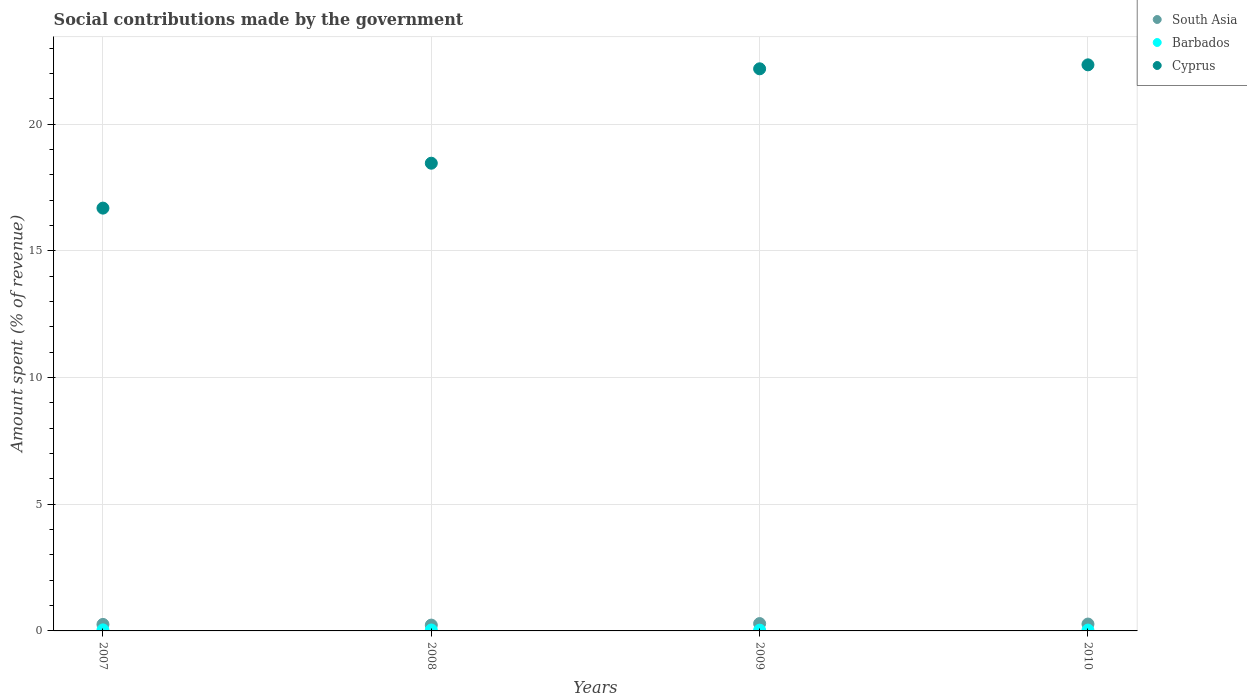What is the amount spent (in %) on social contributions in Barbados in 2010?
Your answer should be compact. 0.03. Across all years, what is the maximum amount spent (in %) on social contributions in South Asia?
Keep it short and to the point. 0.29. Across all years, what is the minimum amount spent (in %) on social contributions in Cyprus?
Offer a terse response. 16.69. In which year was the amount spent (in %) on social contributions in Cyprus minimum?
Provide a succinct answer. 2007. What is the total amount spent (in %) on social contributions in South Asia in the graph?
Ensure brevity in your answer.  1.05. What is the difference between the amount spent (in %) on social contributions in Barbados in 2007 and that in 2009?
Your answer should be compact. 0.01. What is the difference between the amount spent (in %) on social contributions in Barbados in 2009 and the amount spent (in %) on social contributions in Cyprus in 2007?
Your response must be concise. -16.66. What is the average amount spent (in %) on social contributions in Barbados per year?
Provide a short and direct response. 0.03. In the year 2009, what is the difference between the amount spent (in %) on social contributions in South Asia and amount spent (in %) on social contributions in Cyprus?
Offer a terse response. -21.9. In how many years, is the amount spent (in %) on social contributions in South Asia greater than 12 %?
Offer a terse response. 0. What is the ratio of the amount spent (in %) on social contributions in South Asia in 2007 to that in 2008?
Provide a short and direct response. 1.12. Is the difference between the amount spent (in %) on social contributions in South Asia in 2009 and 2010 greater than the difference between the amount spent (in %) on social contributions in Cyprus in 2009 and 2010?
Offer a very short reply. Yes. What is the difference between the highest and the second highest amount spent (in %) on social contributions in Cyprus?
Give a very brief answer. 0.16. What is the difference between the highest and the lowest amount spent (in %) on social contributions in Cyprus?
Give a very brief answer. 5.66. Is the amount spent (in %) on social contributions in South Asia strictly greater than the amount spent (in %) on social contributions in Cyprus over the years?
Make the answer very short. No. Is the amount spent (in %) on social contributions in Cyprus strictly less than the amount spent (in %) on social contributions in Barbados over the years?
Offer a terse response. No. How many dotlines are there?
Your answer should be very brief. 3. Where does the legend appear in the graph?
Your answer should be compact. Top right. What is the title of the graph?
Give a very brief answer. Social contributions made by the government. What is the label or title of the Y-axis?
Provide a succinct answer. Amount spent (% of revenue). What is the Amount spent (% of revenue) of South Asia in 2007?
Provide a short and direct response. 0.26. What is the Amount spent (% of revenue) in Barbados in 2007?
Provide a short and direct response. 0.04. What is the Amount spent (% of revenue) in Cyprus in 2007?
Provide a succinct answer. 16.69. What is the Amount spent (% of revenue) in South Asia in 2008?
Ensure brevity in your answer.  0.23. What is the Amount spent (% of revenue) in Barbados in 2008?
Your response must be concise. 0.04. What is the Amount spent (% of revenue) in Cyprus in 2008?
Provide a short and direct response. 18.46. What is the Amount spent (% of revenue) in South Asia in 2009?
Provide a short and direct response. 0.29. What is the Amount spent (% of revenue) in Barbados in 2009?
Make the answer very short. 0.03. What is the Amount spent (% of revenue) of Cyprus in 2009?
Provide a short and direct response. 22.19. What is the Amount spent (% of revenue) in South Asia in 2010?
Offer a very short reply. 0.27. What is the Amount spent (% of revenue) of Barbados in 2010?
Give a very brief answer. 0.03. What is the Amount spent (% of revenue) of Cyprus in 2010?
Offer a very short reply. 22.35. Across all years, what is the maximum Amount spent (% of revenue) in South Asia?
Provide a short and direct response. 0.29. Across all years, what is the maximum Amount spent (% of revenue) in Barbados?
Your answer should be compact. 0.04. Across all years, what is the maximum Amount spent (% of revenue) in Cyprus?
Provide a succinct answer. 22.35. Across all years, what is the minimum Amount spent (% of revenue) in South Asia?
Make the answer very short. 0.23. Across all years, what is the minimum Amount spent (% of revenue) of Barbados?
Keep it short and to the point. 0.03. Across all years, what is the minimum Amount spent (% of revenue) in Cyprus?
Your answer should be very brief. 16.69. What is the total Amount spent (% of revenue) in South Asia in the graph?
Provide a short and direct response. 1.05. What is the total Amount spent (% of revenue) of Barbados in the graph?
Make the answer very short. 0.14. What is the total Amount spent (% of revenue) in Cyprus in the graph?
Your answer should be very brief. 79.69. What is the difference between the Amount spent (% of revenue) in South Asia in 2007 and that in 2008?
Your answer should be very brief. 0.03. What is the difference between the Amount spent (% of revenue) in Barbados in 2007 and that in 2008?
Your answer should be very brief. 0. What is the difference between the Amount spent (% of revenue) of Cyprus in 2007 and that in 2008?
Your answer should be compact. -1.77. What is the difference between the Amount spent (% of revenue) in South Asia in 2007 and that in 2009?
Give a very brief answer. -0.03. What is the difference between the Amount spent (% of revenue) in Barbados in 2007 and that in 2009?
Keep it short and to the point. 0.01. What is the difference between the Amount spent (% of revenue) of Cyprus in 2007 and that in 2009?
Provide a short and direct response. -5.5. What is the difference between the Amount spent (% of revenue) of South Asia in 2007 and that in 2010?
Ensure brevity in your answer.  -0.01. What is the difference between the Amount spent (% of revenue) in Barbados in 2007 and that in 2010?
Offer a very short reply. 0.01. What is the difference between the Amount spent (% of revenue) of Cyprus in 2007 and that in 2010?
Give a very brief answer. -5.66. What is the difference between the Amount spent (% of revenue) in South Asia in 2008 and that in 2009?
Your answer should be compact. -0.06. What is the difference between the Amount spent (% of revenue) of Barbados in 2008 and that in 2009?
Keep it short and to the point. 0.01. What is the difference between the Amount spent (% of revenue) of Cyprus in 2008 and that in 2009?
Offer a very short reply. -3.73. What is the difference between the Amount spent (% of revenue) in South Asia in 2008 and that in 2010?
Offer a very short reply. -0.04. What is the difference between the Amount spent (% of revenue) of Barbados in 2008 and that in 2010?
Offer a terse response. 0. What is the difference between the Amount spent (% of revenue) in Cyprus in 2008 and that in 2010?
Provide a succinct answer. -3.88. What is the difference between the Amount spent (% of revenue) in South Asia in 2009 and that in 2010?
Provide a succinct answer. 0.02. What is the difference between the Amount spent (% of revenue) in Barbados in 2009 and that in 2010?
Your answer should be very brief. -0. What is the difference between the Amount spent (% of revenue) in Cyprus in 2009 and that in 2010?
Give a very brief answer. -0.16. What is the difference between the Amount spent (% of revenue) in South Asia in 2007 and the Amount spent (% of revenue) in Barbados in 2008?
Make the answer very short. 0.22. What is the difference between the Amount spent (% of revenue) in South Asia in 2007 and the Amount spent (% of revenue) in Cyprus in 2008?
Ensure brevity in your answer.  -18.21. What is the difference between the Amount spent (% of revenue) in Barbados in 2007 and the Amount spent (% of revenue) in Cyprus in 2008?
Your answer should be very brief. -18.42. What is the difference between the Amount spent (% of revenue) of South Asia in 2007 and the Amount spent (% of revenue) of Barbados in 2009?
Keep it short and to the point. 0.23. What is the difference between the Amount spent (% of revenue) in South Asia in 2007 and the Amount spent (% of revenue) in Cyprus in 2009?
Give a very brief answer. -21.93. What is the difference between the Amount spent (% of revenue) of Barbados in 2007 and the Amount spent (% of revenue) of Cyprus in 2009?
Your response must be concise. -22.15. What is the difference between the Amount spent (% of revenue) in South Asia in 2007 and the Amount spent (% of revenue) in Barbados in 2010?
Ensure brevity in your answer.  0.22. What is the difference between the Amount spent (% of revenue) in South Asia in 2007 and the Amount spent (% of revenue) in Cyprus in 2010?
Give a very brief answer. -22.09. What is the difference between the Amount spent (% of revenue) in Barbados in 2007 and the Amount spent (% of revenue) in Cyprus in 2010?
Keep it short and to the point. -22.31. What is the difference between the Amount spent (% of revenue) in South Asia in 2008 and the Amount spent (% of revenue) in Barbados in 2009?
Your answer should be very brief. 0.2. What is the difference between the Amount spent (% of revenue) of South Asia in 2008 and the Amount spent (% of revenue) of Cyprus in 2009?
Keep it short and to the point. -21.96. What is the difference between the Amount spent (% of revenue) in Barbados in 2008 and the Amount spent (% of revenue) in Cyprus in 2009?
Give a very brief answer. -22.15. What is the difference between the Amount spent (% of revenue) of South Asia in 2008 and the Amount spent (% of revenue) of Barbados in 2010?
Your answer should be compact. 0.2. What is the difference between the Amount spent (% of revenue) in South Asia in 2008 and the Amount spent (% of revenue) in Cyprus in 2010?
Your answer should be very brief. -22.12. What is the difference between the Amount spent (% of revenue) in Barbados in 2008 and the Amount spent (% of revenue) in Cyprus in 2010?
Ensure brevity in your answer.  -22.31. What is the difference between the Amount spent (% of revenue) of South Asia in 2009 and the Amount spent (% of revenue) of Barbados in 2010?
Offer a terse response. 0.26. What is the difference between the Amount spent (% of revenue) of South Asia in 2009 and the Amount spent (% of revenue) of Cyprus in 2010?
Give a very brief answer. -22.06. What is the difference between the Amount spent (% of revenue) of Barbados in 2009 and the Amount spent (% of revenue) of Cyprus in 2010?
Your answer should be very brief. -22.32. What is the average Amount spent (% of revenue) in South Asia per year?
Make the answer very short. 0.26. What is the average Amount spent (% of revenue) of Barbados per year?
Your response must be concise. 0.03. What is the average Amount spent (% of revenue) of Cyprus per year?
Give a very brief answer. 19.92. In the year 2007, what is the difference between the Amount spent (% of revenue) of South Asia and Amount spent (% of revenue) of Barbados?
Offer a terse response. 0.22. In the year 2007, what is the difference between the Amount spent (% of revenue) of South Asia and Amount spent (% of revenue) of Cyprus?
Your answer should be compact. -16.43. In the year 2007, what is the difference between the Amount spent (% of revenue) in Barbados and Amount spent (% of revenue) in Cyprus?
Give a very brief answer. -16.65. In the year 2008, what is the difference between the Amount spent (% of revenue) in South Asia and Amount spent (% of revenue) in Barbados?
Make the answer very short. 0.19. In the year 2008, what is the difference between the Amount spent (% of revenue) of South Asia and Amount spent (% of revenue) of Cyprus?
Ensure brevity in your answer.  -18.23. In the year 2008, what is the difference between the Amount spent (% of revenue) of Barbados and Amount spent (% of revenue) of Cyprus?
Ensure brevity in your answer.  -18.43. In the year 2009, what is the difference between the Amount spent (% of revenue) in South Asia and Amount spent (% of revenue) in Barbados?
Make the answer very short. 0.26. In the year 2009, what is the difference between the Amount spent (% of revenue) of South Asia and Amount spent (% of revenue) of Cyprus?
Keep it short and to the point. -21.9. In the year 2009, what is the difference between the Amount spent (% of revenue) in Barbados and Amount spent (% of revenue) in Cyprus?
Your answer should be compact. -22.16. In the year 2010, what is the difference between the Amount spent (% of revenue) in South Asia and Amount spent (% of revenue) in Barbados?
Your response must be concise. 0.24. In the year 2010, what is the difference between the Amount spent (% of revenue) of South Asia and Amount spent (% of revenue) of Cyprus?
Offer a terse response. -22.07. In the year 2010, what is the difference between the Amount spent (% of revenue) of Barbados and Amount spent (% of revenue) of Cyprus?
Ensure brevity in your answer.  -22.31. What is the ratio of the Amount spent (% of revenue) of South Asia in 2007 to that in 2008?
Offer a terse response. 1.12. What is the ratio of the Amount spent (% of revenue) of Barbados in 2007 to that in 2008?
Keep it short and to the point. 1.12. What is the ratio of the Amount spent (% of revenue) of Cyprus in 2007 to that in 2008?
Keep it short and to the point. 0.9. What is the ratio of the Amount spent (% of revenue) of South Asia in 2007 to that in 2009?
Your answer should be compact. 0.89. What is the ratio of the Amount spent (% of revenue) of Barbados in 2007 to that in 2009?
Make the answer very short. 1.35. What is the ratio of the Amount spent (% of revenue) in Cyprus in 2007 to that in 2009?
Your answer should be very brief. 0.75. What is the ratio of the Amount spent (% of revenue) of South Asia in 2007 to that in 2010?
Provide a succinct answer. 0.95. What is the ratio of the Amount spent (% of revenue) in Barbados in 2007 to that in 2010?
Ensure brevity in your answer.  1.25. What is the ratio of the Amount spent (% of revenue) of Cyprus in 2007 to that in 2010?
Give a very brief answer. 0.75. What is the ratio of the Amount spent (% of revenue) in South Asia in 2008 to that in 2009?
Provide a short and direct response. 0.79. What is the ratio of the Amount spent (% of revenue) of Barbados in 2008 to that in 2009?
Keep it short and to the point. 1.21. What is the ratio of the Amount spent (% of revenue) of Cyprus in 2008 to that in 2009?
Provide a short and direct response. 0.83. What is the ratio of the Amount spent (% of revenue) in South Asia in 2008 to that in 2010?
Your answer should be very brief. 0.85. What is the ratio of the Amount spent (% of revenue) of Barbados in 2008 to that in 2010?
Offer a terse response. 1.12. What is the ratio of the Amount spent (% of revenue) of Cyprus in 2008 to that in 2010?
Provide a succinct answer. 0.83. What is the ratio of the Amount spent (% of revenue) of South Asia in 2009 to that in 2010?
Keep it short and to the point. 1.07. What is the ratio of the Amount spent (% of revenue) in Barbados in 2009 to that in 2010?
Provide a succinct answer. 0.92. What is the difference between the highest and the second highest Amount spent (% of revenue) in South Asia?
Your answer should be compact. 0.02. What is the difference between the highest and the second highest Amount spent (% of revenue) of Barbados?
Offer a very short reply. 0. What is the difference between the highest and the second highest Amount spent (% of revenue) of Cyprus?
Your answer should be very brief. 0.16. What is the difference between the highest and the lowest Amount spent (% of revenue) in South Asia?
Your response must be concise. 0.06. What is the difference between the highest and the lowest Amount spent (% of revenue) in Barbados?
Your answer should be very brief. 0.01. What is the difference between the highest and the lowest Amount spent (% of revenue) in Cyprus?
Offer a very short reply. 5.66. 